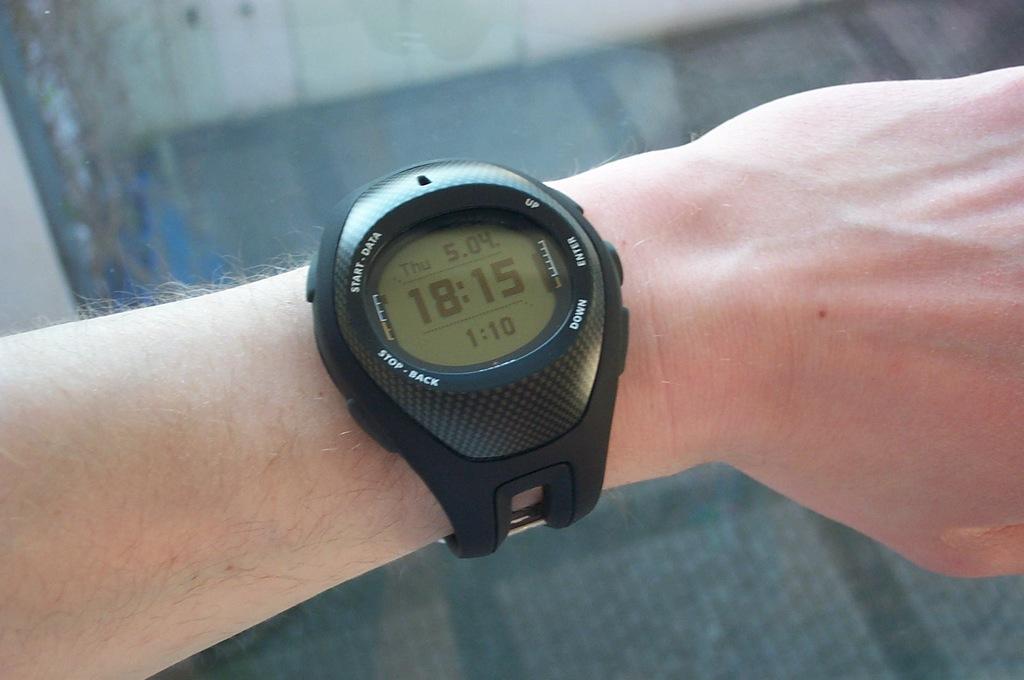What day of the week is it?
Make the answer very short. Thursday. What time is on his watch?
Provide a succinct answer. 18:15. 